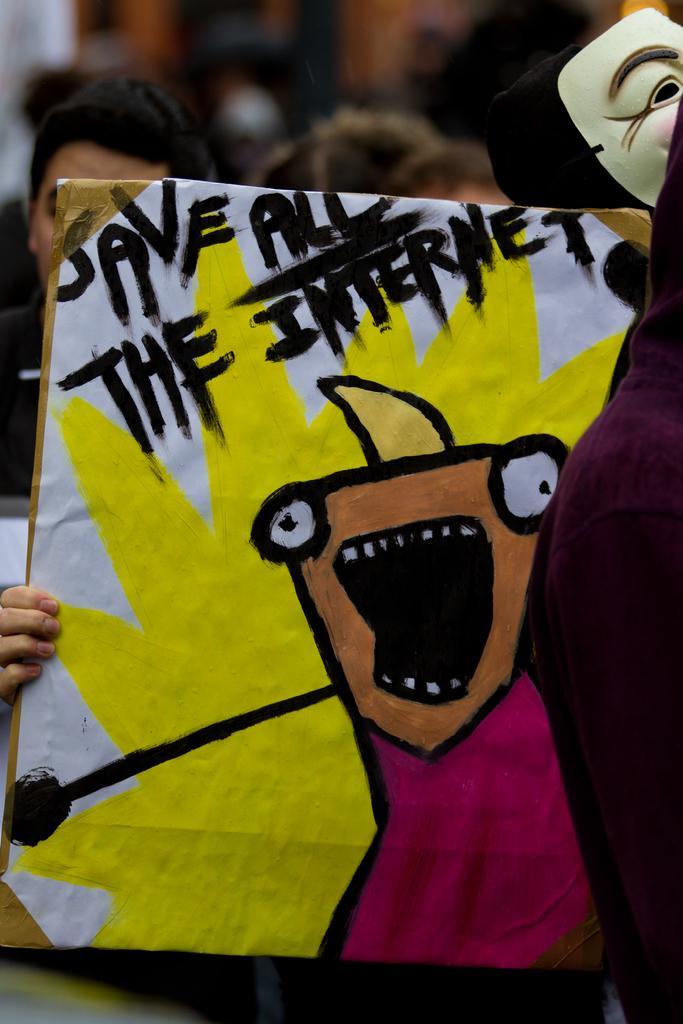Describe this image in one or two sentences. In this image we can see a person holding placard on which we can see some art. Here we can see the mask. The background of the image is slightly blurred, where we can see a few more people. 